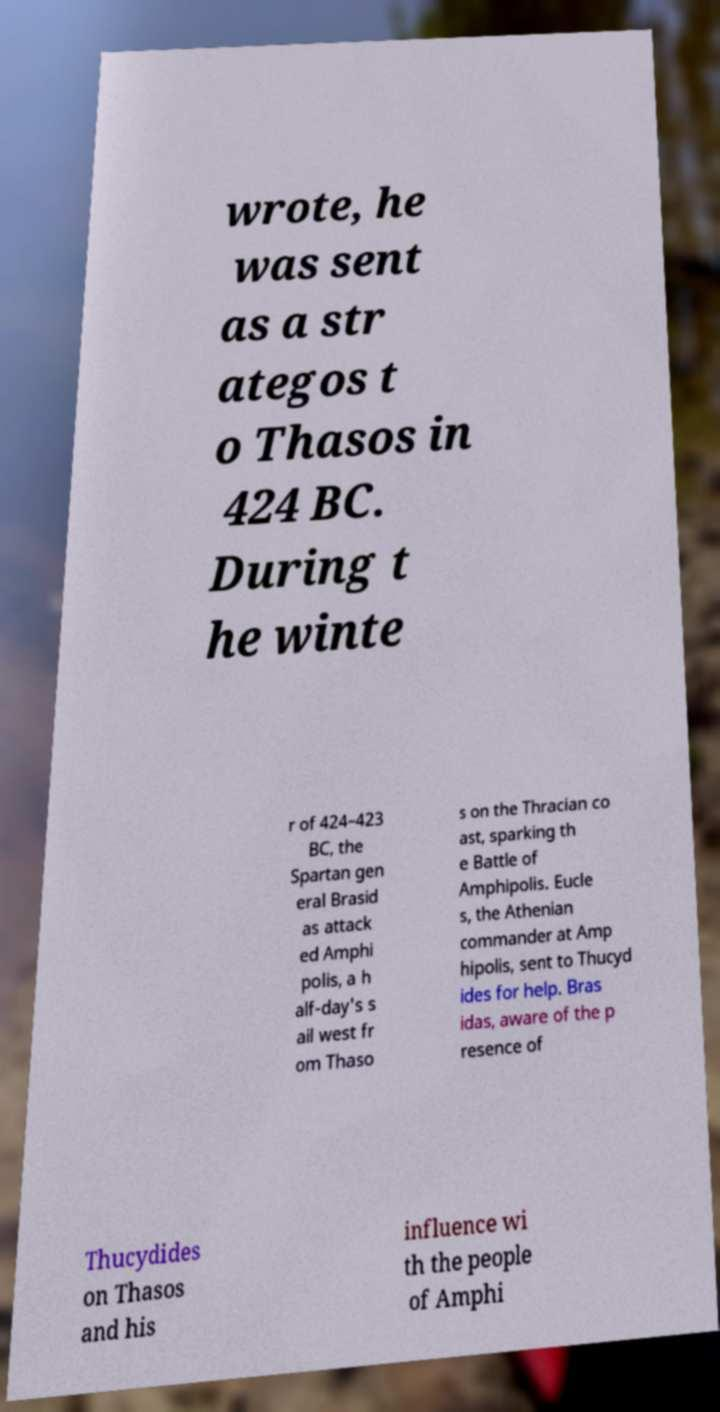There's text embedded in this image that I need extracted. Can you transcribe it verbatim? wrote, he was sent as a str ategos t o Thasos in 424 BC. During t he winte r of 424–423 BC, the Spartan gen eral Brasid as attack ed Amphi polis, a h alf-day's s ail west fr om Thaso s on the Thracian co ast, sparking th e Battle of Amphipolis. Eucle s, the Athenian commander at Amp hipolis, sent to Thucyd ides for help. Bras idas, aware of the p resence of Thucydides on Thasos and his influence wi th the people of Amphi 